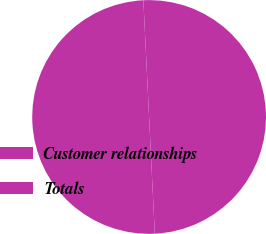Convert chart. <chart><loc_0><loc_0><loc_500><loc_500><pie_chart><fcel>Customer relationships<fcel>Totals<nl><fcel>50.0%<fcel>50.0%<nl></chart> 